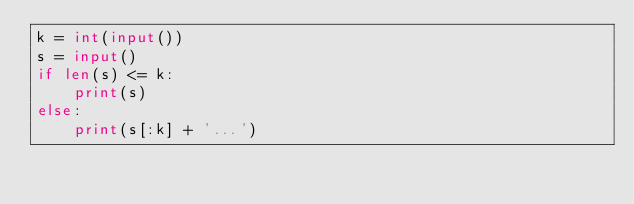Convert code to text. <code><loc_0><loc_0><loc_500><loc_500><_Python_>k = int(input())
s = input()
if len(s) <= k:
    print(s)
else:
    print(s[:k] + '...')
    
</code> 